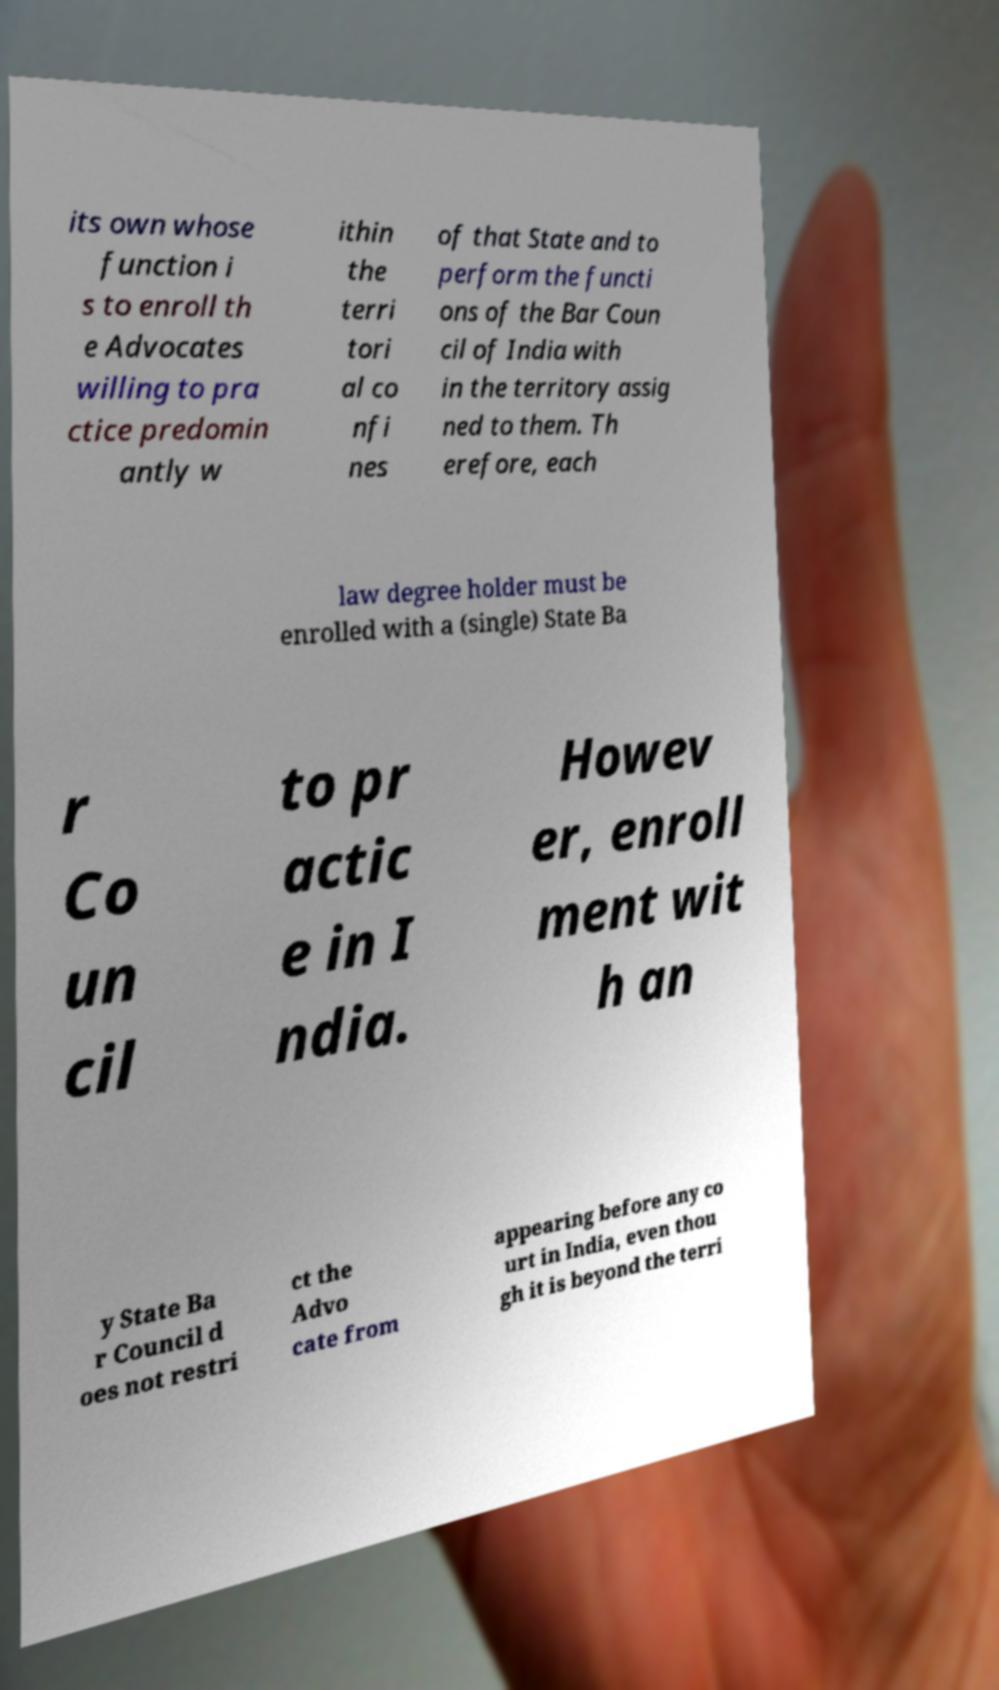I need the written content from this picture converted into text. Can you do that? its own whose function i s to enroll th e Advocates willing to pra ctice predomin antly w ithin the terri tori al co nfi nes of that State and to perform the functi ons of the Bar Coun cil of India with in the territory assig ned to them. Th erefore, each law degree holder must be enrolled with a (single) State Ba r Co un cil to pr actic e in I ndia. Howev er, enroll ment wit h an y State Ba r Council d oes not restri ct the Advo cate from appearing before any co urt in India, even thou gh it is beyond the terri 